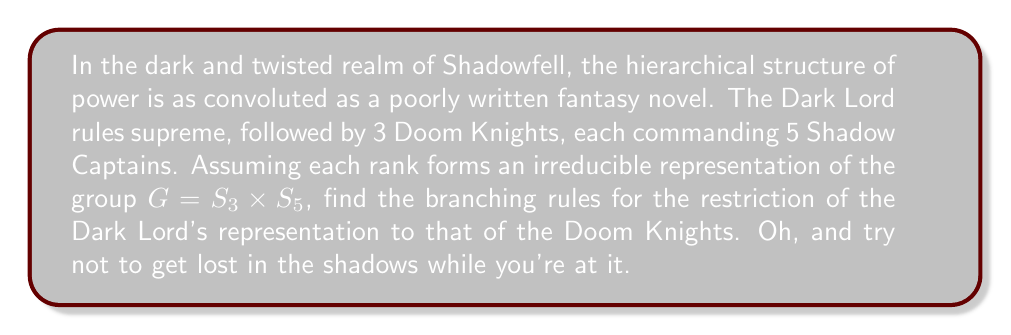Solve this math problem. Alright, let's delve into this gloomy mathematical abyss:

1) First, we need to identify the representations:
   - Dark Lord: trivial representation of $G = S_3 \times S_5$, denoted as $(1,1)$
   - Doom Knights: standard representation of $S_3$, tensor product with trivial rep of $S_5$, denoted as $(3,1)$

2) The branching rule will describe how $(1,1)$ decomposes when restricted to the subgroup $H = S_3 \times 1 \subset G$

3) For $S_3$, the character table is:
   $$
   \begin{array}{c|ccc}
    & [1^3] & [2,1] & [3] \\
   \hline
   \chi_{(1)} & 1 & 1 & 1 \\
   \chi_{(2,1)} & 2 & 0 & -1 \\
   \chi_{(3)} & 1 & -1 & 1
   \end{array}
   $$

4) The restriction of $(1,1)$ to $H$ is simply the trivial representation of $S_3$, which corresponds to the partition $(3)$

5) Therefore, the branching rule is:
   $$(1,1) \downarrow^G_H = (3)$$

6) In terms of dimensions:
   $$1 = 1$$

   Which, unsurprisingly, tells us that one Dark Lord is still just one entity, even when viewed from the perspective of the Doom Knights. How disappointingly straightforward for a realm of shadows.
Answer: $(1,1) \downarrow^G_H = (3)$ 